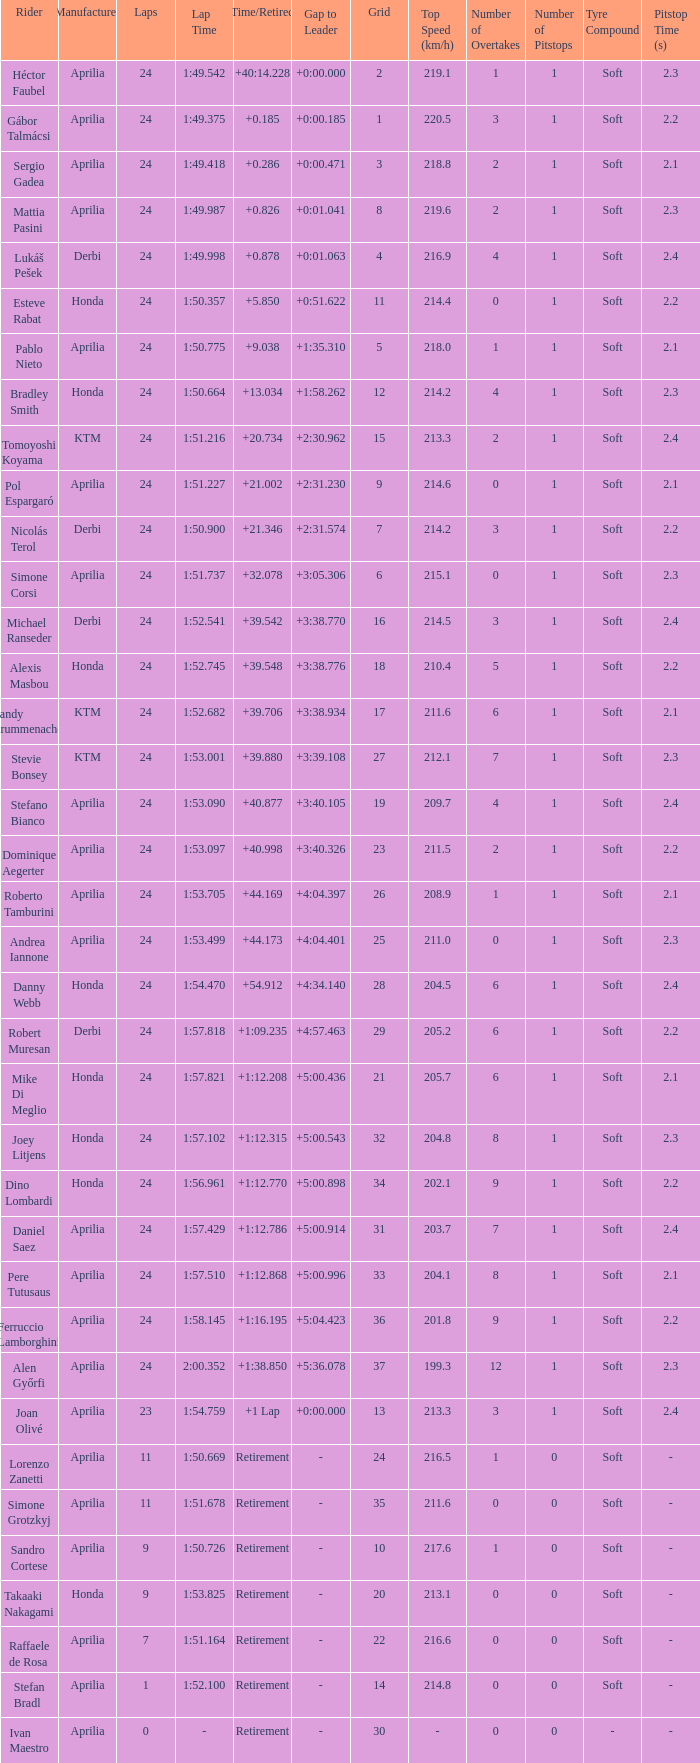How many grids correspond to in excess of 24 laps? None. 